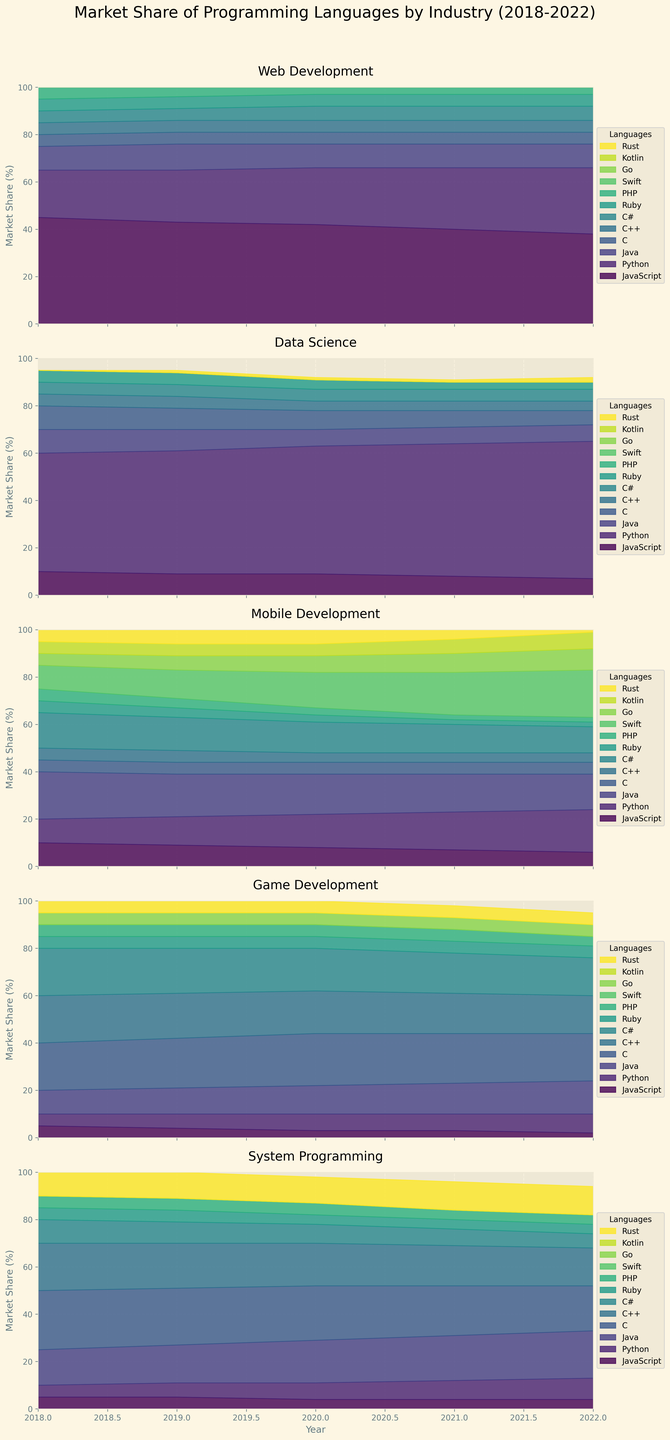What is the title of the chart? The title is located at the top center of the chart, and it reads "Market Share of Programming Languages by Industry (2018-2022)"
Answer: Market Share of Programming Languages by Industry (2018-2022) Which year shows the highest market share for Python in Data Science? By looking at the segment for Python in the Data Science industry, we see that Python's market share increases each year. The highest segment for Python is found in 2022.
Answer: 2022 What is the trend of JavaScript's market share in Web Development over the years? In the Web Development section, examine the JavaScript area, which consistently decreases slightly year by year from 2018 (45%) to 2022 (38%).
Answer: Decreasing In which industry does C++ have the least influence, based on the market share? By comparing the segments for C++ across the different industries, it is clear that C++ has the least market share in Web Development across all the years.
Answer: Web Development How does the market share of Swift in Mobile Development change from 2018 to 2022? Observe the Swift segment in Mobile Development from 2018 through 2022. The segment increases from 10% in 2018 to 20% in 2022.
Answer: Increasing Between 2018 and 2022, which industry shows the most consistent trend for the use of C#? By looking at the C# segments in each industry, it's evident that the trend of C# usage remains fairly constant in Web Development and Mobile Development, but Web Development shows more consistency with only minor variations.
Answer: Web Development What is the combined market share for Rust and Go in System Programming for 2022? In the System Programming industry for 2022, the segments for Rust and Go are visible. Rust's market share is 12% and Go's is 0%. Adding these gives 12% + 0% = 12%.
Answer: 12% Which programming languages appear in all industries with at least some market share? By examining all the color segments across each industry, we can identify that C shows presence in all industries with some market share in each one.
Answer: C Which industry has the highest variation in total market share allocation among programming languages over the five years? Assess the height differences in segments from year to year across all industries. Game Development and System Programming show noticeable changes in language shares, but upon closer inspection, System Programming fluctuates more dramatically.
Answer: System Programming 